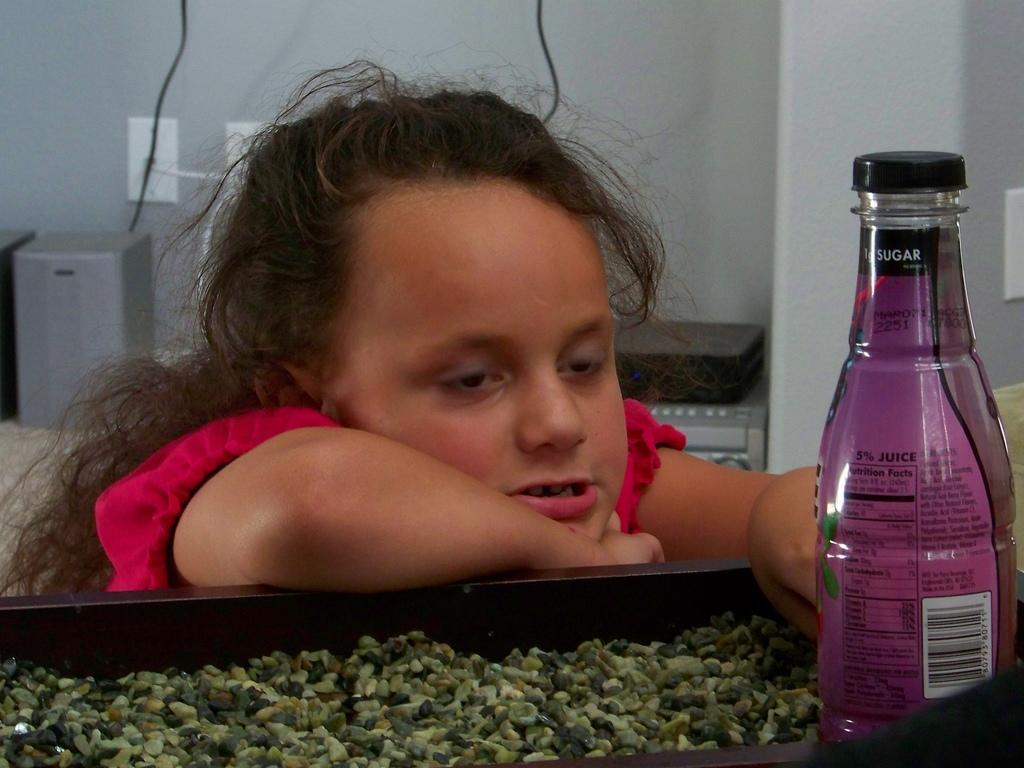What is the main subject of the image? The main subject of the image is a kid. What is the kid wearing? The kid is wearing a red dress. What is the kid doing in the image? The kid is touching a bottle. What type of cork can be seen on the kid's head in the image? There is no cork present on the kid's head in the image. What kind of yarn is the kid using to knit a scarf in the image? There is no yarn or knitting activity depicted in the image. 